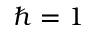Convert formula to latex. <formula><loc_0><loc_0><loc_500><loc_500>\hbar { = } 1</formula> 